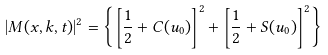Convert formula to latex. <formula><loc_0><loc_0><loc_500><loc_500>| M ( x , k , t ) | ^ { 2 } = \left \{ \left [ \frac { 1 } { 2 } + C ( u _ { 0 } ) \right ] ^ { 2 } + \left [ \frac { 1 } { 2 } + S ( u _ { 0 } ) \right ] ^ { 2 } \right \}</formula> 